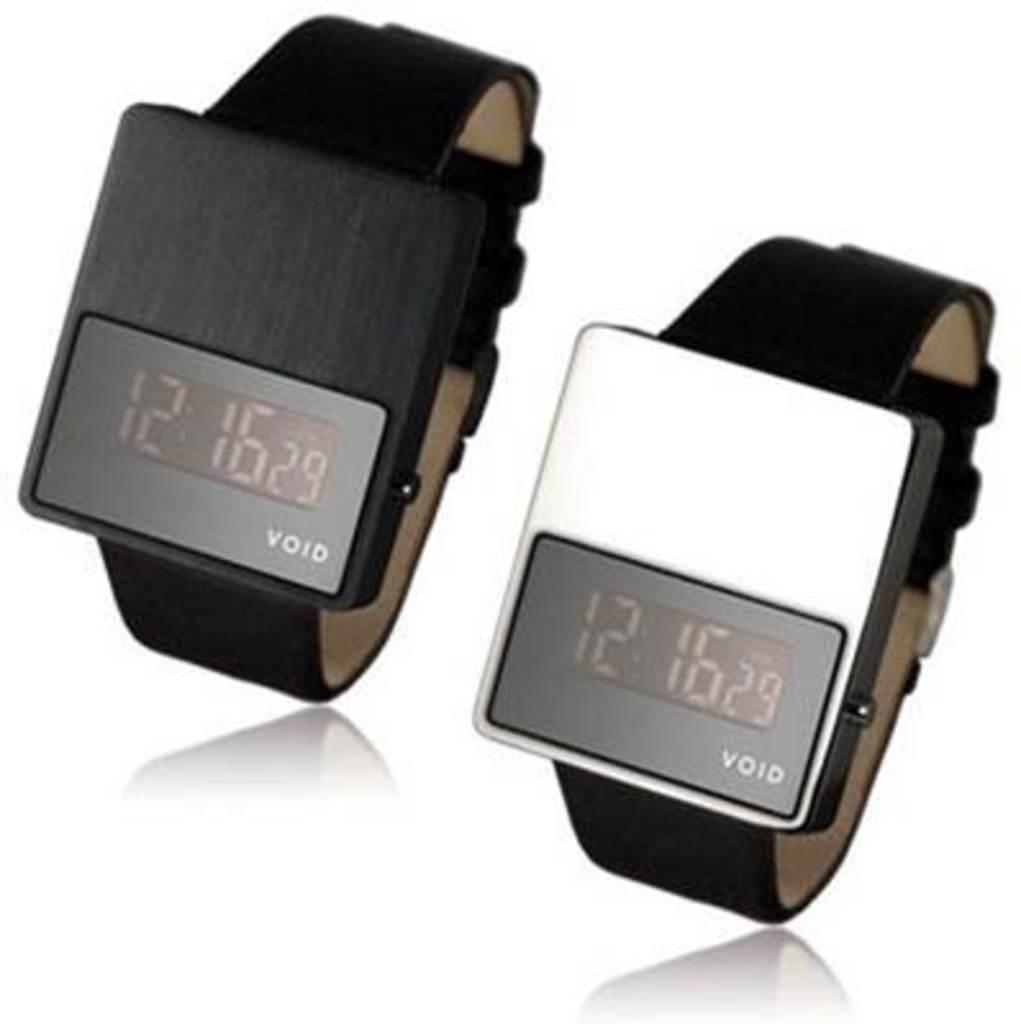<image>
Share a concise interpretation of the image provided. Two watches display that the time is 12:16 and it is the 29th day of the month. 